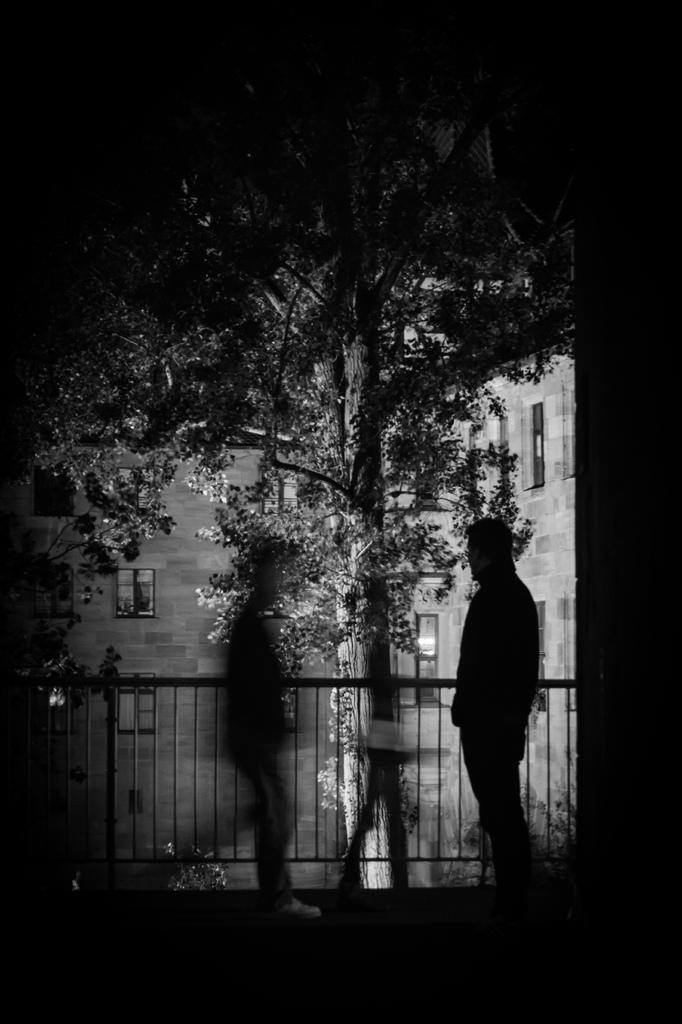What is the color scheme of the image? The image is black and white. What are the people in the image doing? There are people walking in the image. What can be seen in the background of the image? There is a railing, a tree, and a building in the background of the image. What type of songs can be heard playing in the background of the image? There is no audio or indication of music in the image, so it is not possible to determine what songs might be heard. 